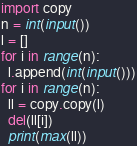<code> <loc_0><loc_0><loc_500><loc_500><_Python_>import copy
n = int(input())
l = []
for i in range(n):
  l.append(int(input()))
for i in range(n):
  ll = copy.copy(l)
  del(ll[i])
  print(max(ll))</code> 